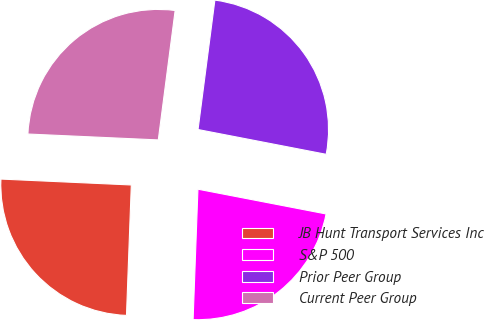Convert chart to OTSL. <chart><loc_0><loc_0><loc_500><loc_500><pie_chart><fcel>JB Hunt Transport Services Inc<fcel>S&P 500<fcel>Prior Peer Group<fcel>Current Peer Group<nl><fcel>25.13%<fcel>22.55%<fcel>25.98%<fcel>26.34%<nl></chart> 